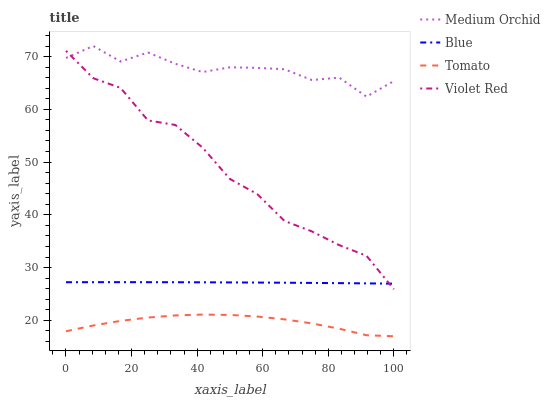Does Violet Red have the minimum area under the curve?
Answer yes or no. No. Does Violet Red have the maximum area under the curve?
Answer yes or no. No. Is Tomato the smoothest?
Answer yes or no. No. Is Tomato the roughest?
Answer yes or no. No. Does Violet Red have the lowest value?
Answer yes or no. No. Does Violet Red have the highest value?
Answer yes or no. No. Is Blue less than Medium Orchid?
Answer yes or no. Yes. Is Medium Orchid greater than Tomato?
Answer yes or no. Yes. Does Blue intersect Medium Orchid?
Answer yes or no. No. 